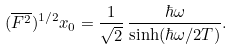<formula> <loc_0><loc_0><loc_500><loc_500>( \overline { F ^ { 2 } } ) ^ { 1 / 2 } x _ { 0 } = \frac { 1 } { \sqrt { 2 } } \, \frac { \hbar { \omega } } { \sinh ( \hbar { \omega } / 2 T ) } .</formula> 